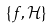<formula> <loc_0><loc_0><loc_500><loc_500>\{ f , { \mathcal { H } } \}</formula> 